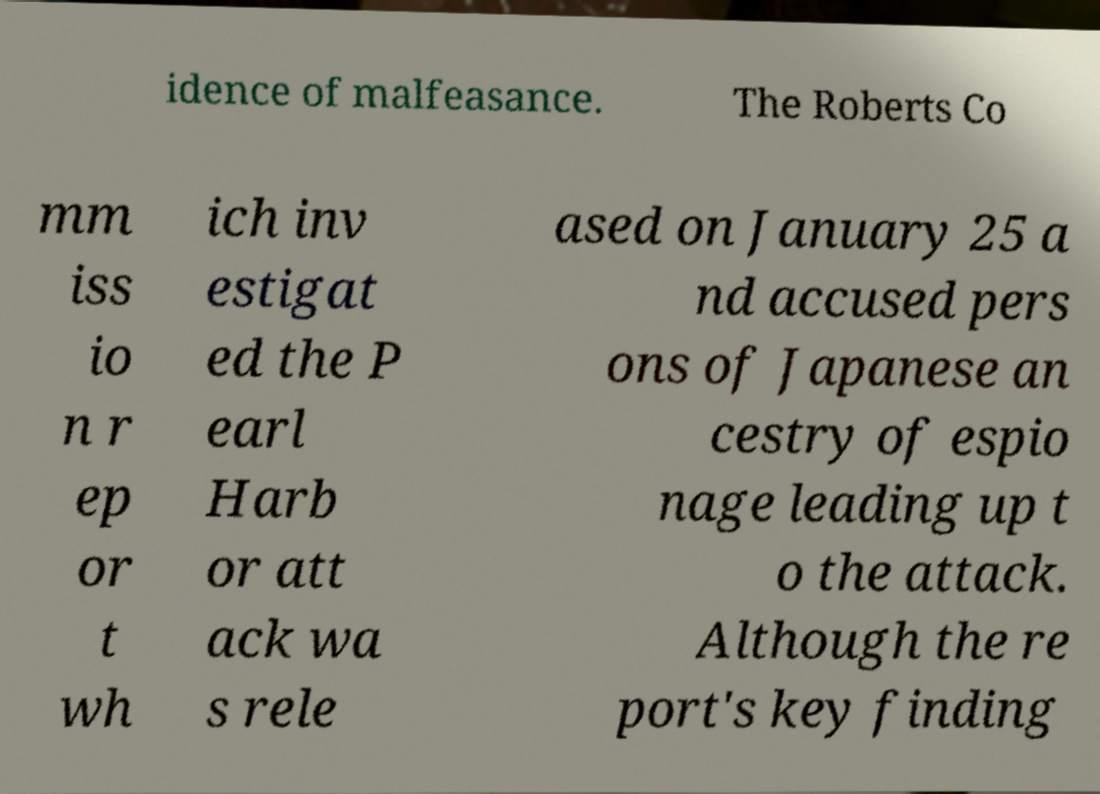What messages or text are displayed in this image? I need them in a readable, typed format. idence of malfeasance. The Roberts Co mm iss io n r ep or t wh ich inv estigat ed the P earl Harb or att ack wa s rele ased on January 25 a nd accused pers ons of Japanese an cestry of espio nage leading up t o the attack. Although the re port's key finding 